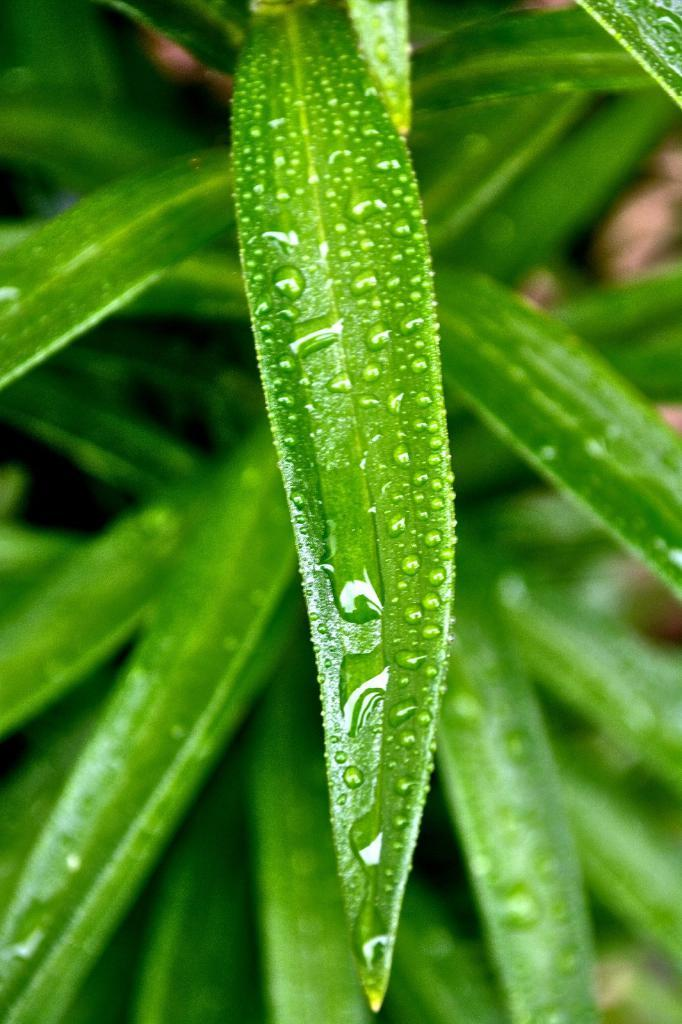What is present in the image? There is a plant in the image. What can be observed on the leaves of the plant? There are water drops on the leaves of the plant. How many leaves are visible at the bottom of the image? There are many leaves visible at the bottom of the image. What direction is the wind blowing in the image? There is no wind present in the image, so it cannot be determined which direction the wind is blowing. 